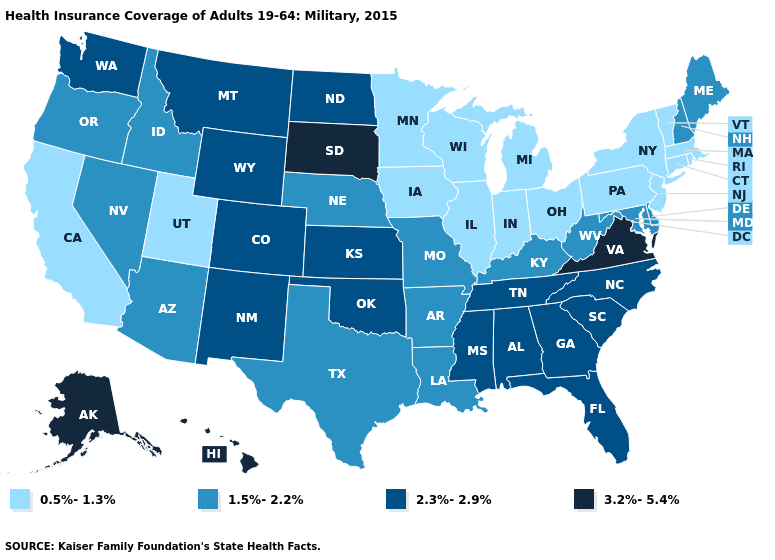Which states hav the highest value in the Northeast?
Short answer required. Maine, New Hampshire. What is the value of Colorado?
Quick response, please. 2.3%-2.9%. What is the value of New Mexico?
Concise answer only. 2.3%-2.9%. Name the states that have a value in the range 0.5%-1.3%?
Keep it brief. California, Connecticut, Illinois, Indiana, Iowa, Massachusetts, Michigan, Minnesota, New Jersey, New York, Ohio, Pennsylvania, Rhode Island, Utah, Vermont, Wisconsin. What is the value of Hawaii?
Be succinct. 3.2%-5.4%. What is the lowest value in the USA?
Concise answer only. 0.5%-1.3%. Does Texas have the same value as Kentucky?
Quick response, please. Yes. What is the value of North Dakota?
Concise answer only. 2.3%-2.9%. What is the value of Connecticut?
Answer briefly. 0.5%-1.3%. What is the highest value in the West ?
Write a very short answer. 3.2%-5.4%. Does Alaska have a lower value than South Carolina?
Be succinct. No. What is the value of Nebraska?
Concise answer only. 1.5%-2.2%. Name the states that have a value in the range 2.3%-2.9%?
Answer briefly. Alabama, Colorado, Florida, Georgia, Kansas, Mississippi, Montana, New Mexico, North Carolina, North Dakota, Oklahoma, South Carolina, Tennessee, Washington, Wyoming. Does the first symbol in the legend represent the smallest category?
Write a very short answer. Yes. Name the states that have a value in the range 2.3%-2.9%?
Be succinct. Alabama, Colorado, Florida, Georgia, Kansas, Mississippi, Montana, New Mexico, North Carolina, North Dakota, Oklahoma, South Carolina, Tennessee, Washington, Wyoming. 